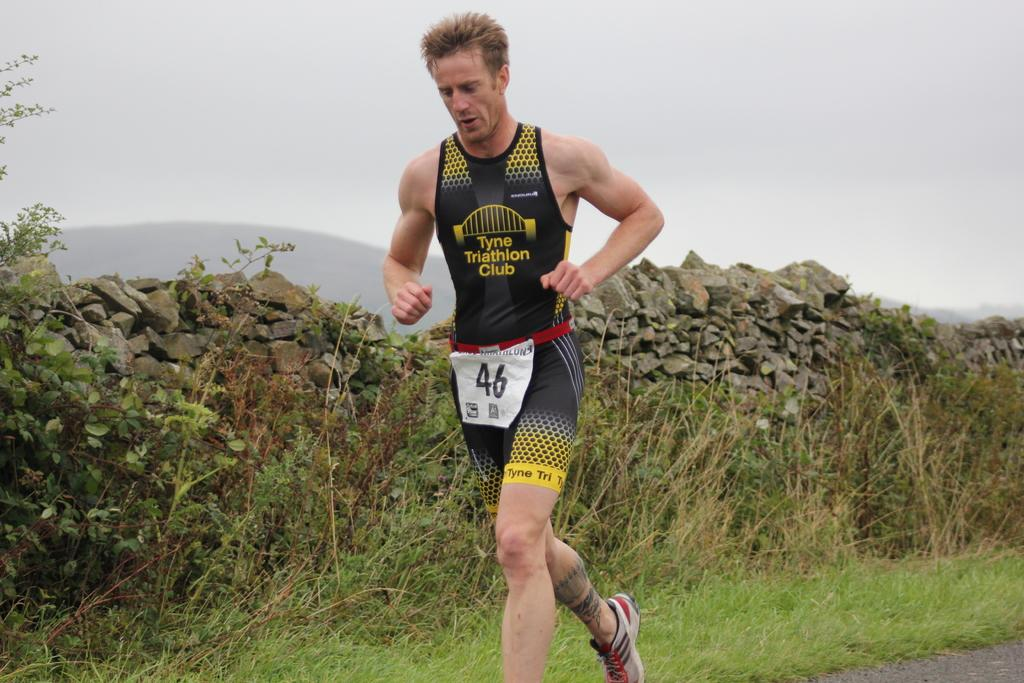<image>
Describe the image concisely. A runner wearing a Tyne Triathlon Club shirt. 